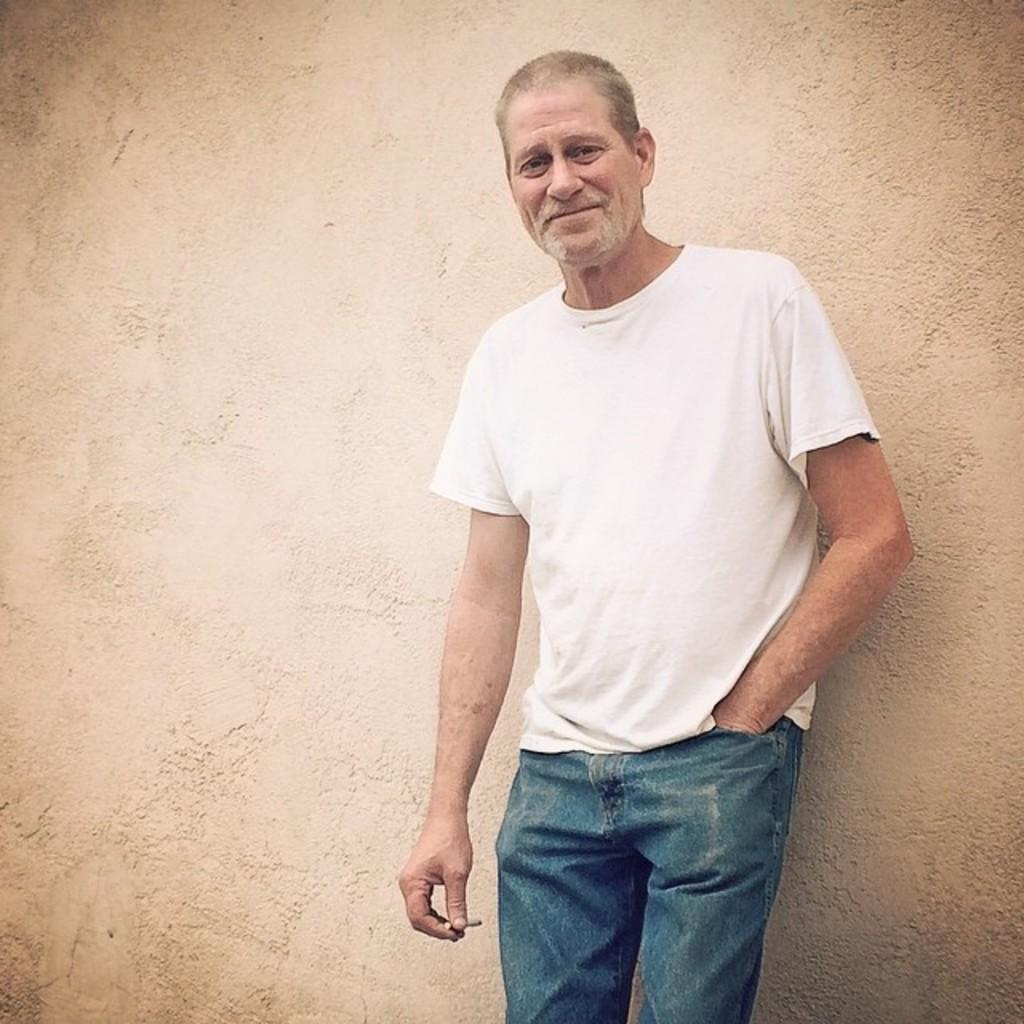What is the person in the image wearing? The person is wearing a white t-shirt. What is the person holding in the image? The person is holding a cigar. What is the person's facial expression in the image? The person is smiling. What can be seen in the background of the image? There is a wall in the background. How many men are visible on the border in the image? There is no mention of a border or men in the image; it features a person wearing a white t-shirt, holding a cigar, and smiling in front of a wall. 